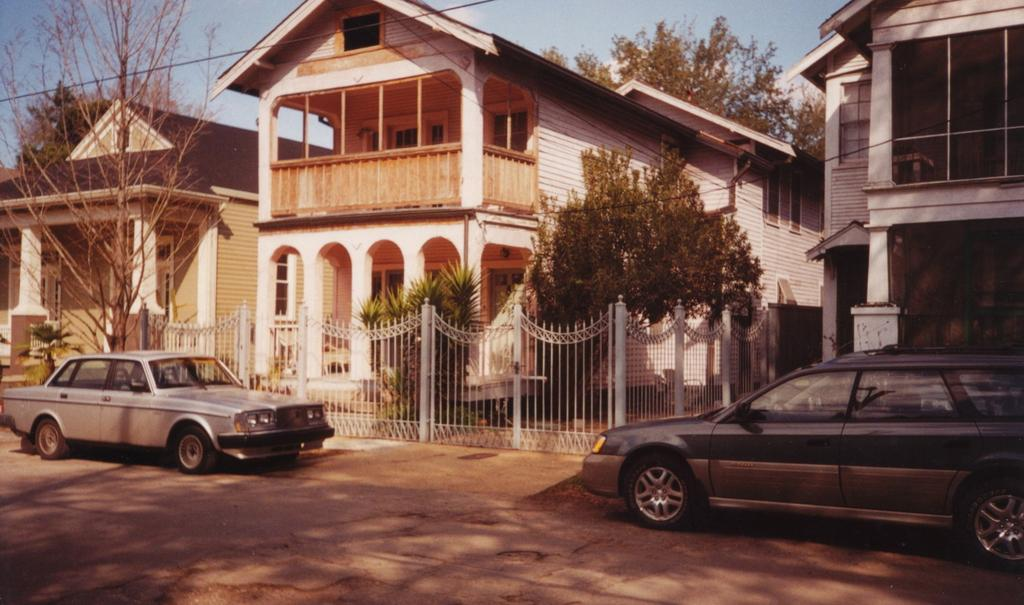What type of structures can be seen in the image? There are buildings in the image, and the sky is blue. What architectural features can be observed on the buildings? There are windows visible in the image. What type of vegetation is present in the image? There are trees in the image. What is the color of the sky in the image? The sky is blue in the image. What type of vehicles can be seen in the image? There are vehicles in the image. What is the color of the gate in the image? There is a white gate in the image. Can you tell me how many hats are visible on the trees in the image? There are no hats present on the trees in the image. What type of animal is using the bag to fly in the image? There is no animal or bag present in the image for flying. 